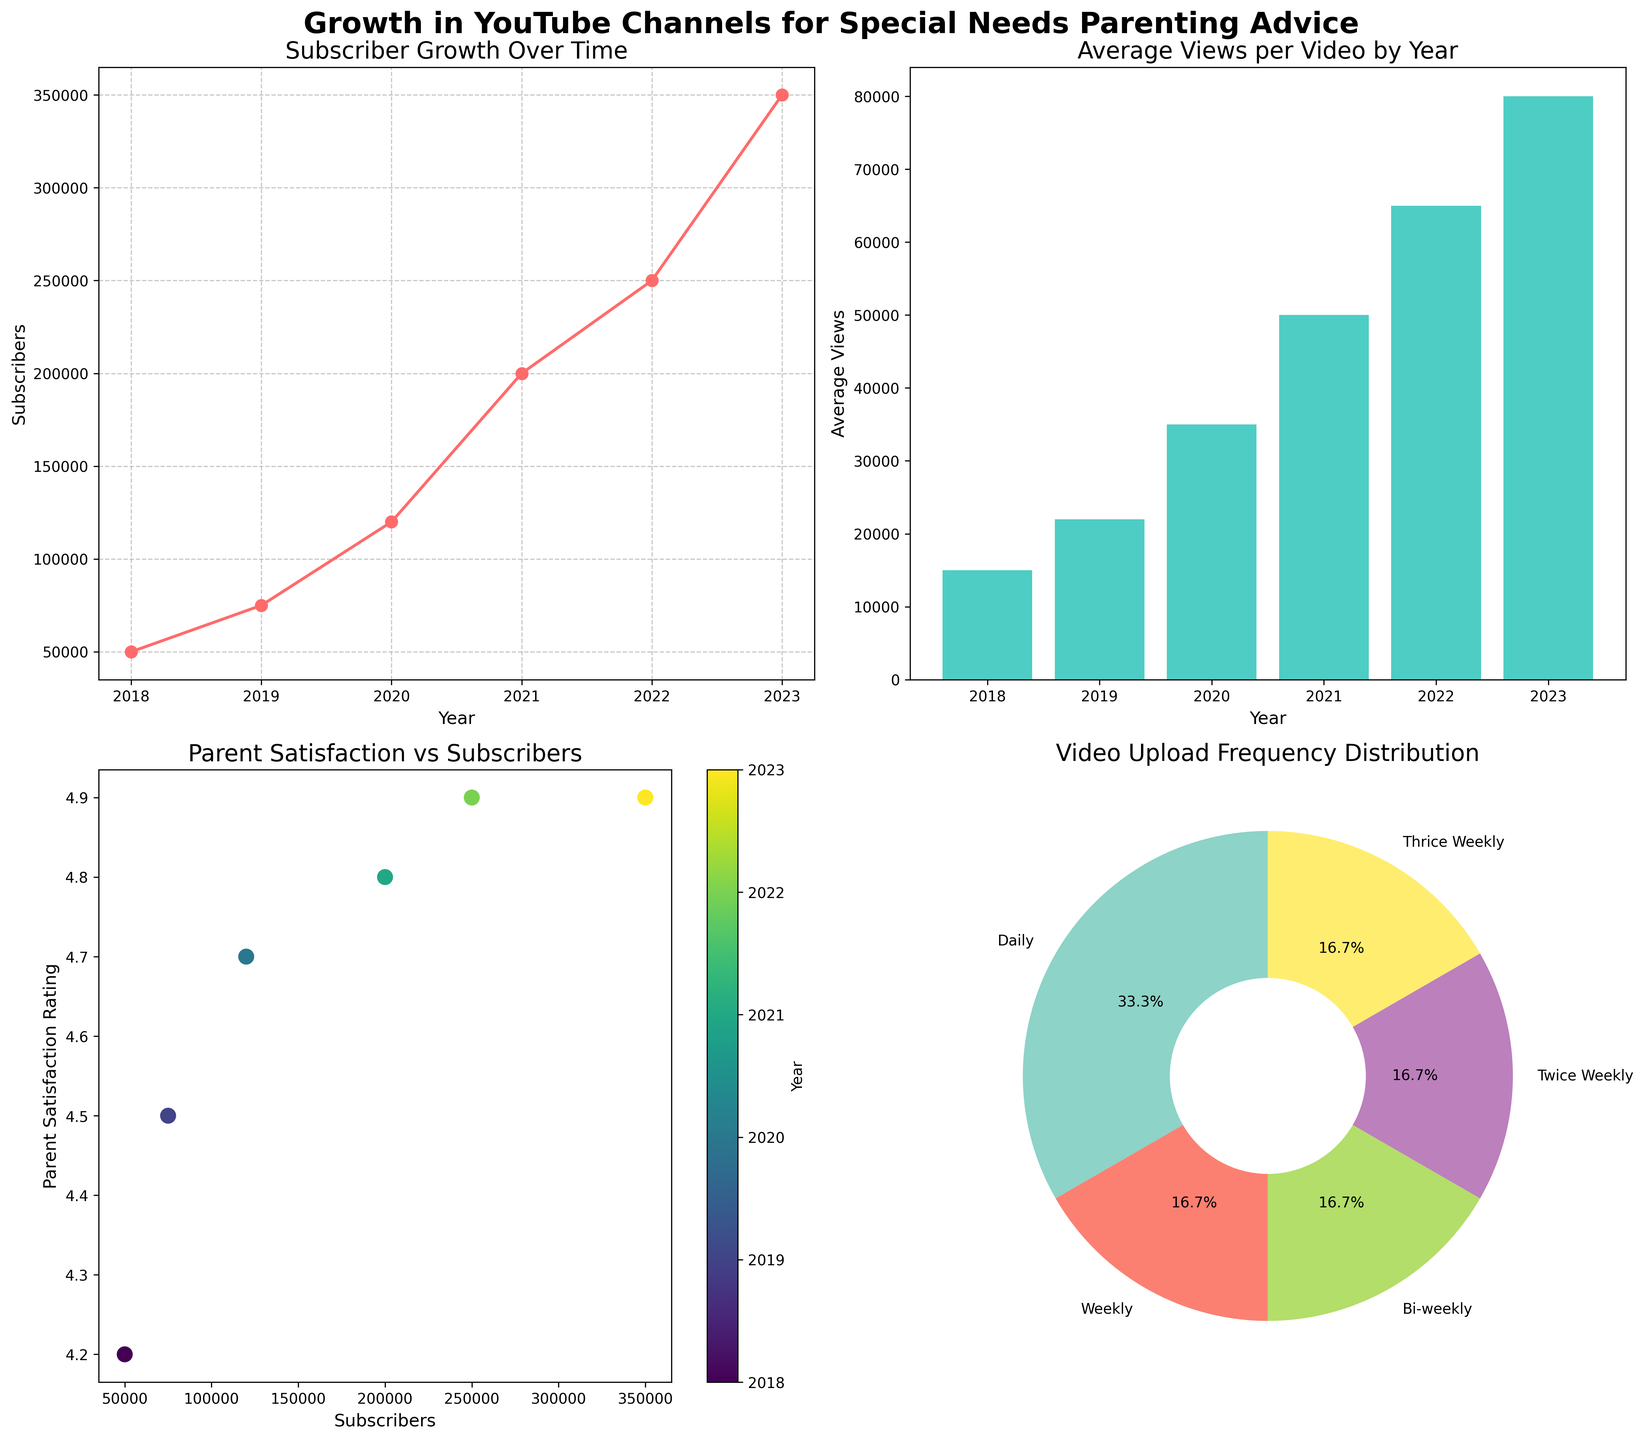What's the title of the figure? The title of the figure is displayed at the top of the plot. It reads "Growth in YouTube Channels for Special Needs Parenting Advice".
Answer: Growth in YouTube Channels for Special Needs Parenting Advice Which year has the highest average views per video? The bar plot in the top right shows the average views per video by year. The tallest bar, representing the highest average views, corresponds to the year 2023.
Answer: 2023 Which channel has the highest parent satisfaction rating? The data labels in the scatter plot on the bottom left represent the satisfaction ratings with subscribers. The highest rating, which is 4.9, is shared by two channels. From observation, the corresponding years (colors in scatter plot) are 2022 and 2023, which match "Down Syndrome Diaries" and "The Inclusive Parent".
Answer: Down Syndrome Diaries, The Inclusive Parent Which year shows the largest increase in subscribers from the previous year? By analyzing the line plot on the top left, the biggest jump in the vertical position of the line is observed between 2022 to 2023, where subscribers went from 250,000 to 350,000, a 100,000 increase.
Answer: 2023 What percentage of video upload frequencies is "Weekly"? The pie chart on the bottom right shows different video upload frequencies and their proportions. To find the percentage for "Weekly", observe its slice size and label. "Weekly" has the smallest slice with a label indicating 16.7%.
Answer: 16.7% How does parent satisfaction rating generally correlate with the number of subscribers? The scatter plot on the bottom left uses different colors to represent years and plots satisfaction rating against subscribers. There's a general trend where higher subscribers are associated with higher satisfaction ratings.
Answer: Higher subscribers correlate with higher satisfaction ratings Comparing 2018 and 2023, how much did the average views per video grow? In the bar plot, the average views per video for 2018 are 15,000 and for 2023 are 80,000. The growth is found by subtracting the 2018 value from the 2023 value: 80,000 - 15,000 = 65,000.
Answer: 65,000 Which year had the highest total subscriber gain compared to the initial year of the dataset? The line plot shows subscriber count over the years. Start at 50,000 in 2018 and see each year's subscriber number up to 2023. The highest gain is by 2023 with subscribers reaching 350,000. So, 350,000 - 50,000 = 300,000.
Answer: 2023, 300,000 What is the most common video upload frequency among the channels? Observing the pie chart, the frequency with the largest slice, representing the highest percentage, is "Daily".
Answer: Daily 